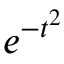Convert formula to latex. <formula><loc_0><loc_0><loc_500><loc_500>e ^ { - t ^ { 2 } }</formula> 